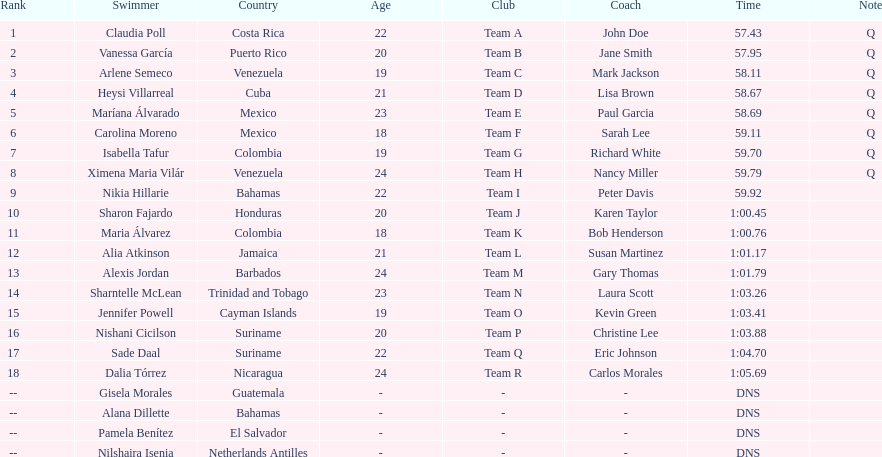How many swimmers are from mexico? 2. 